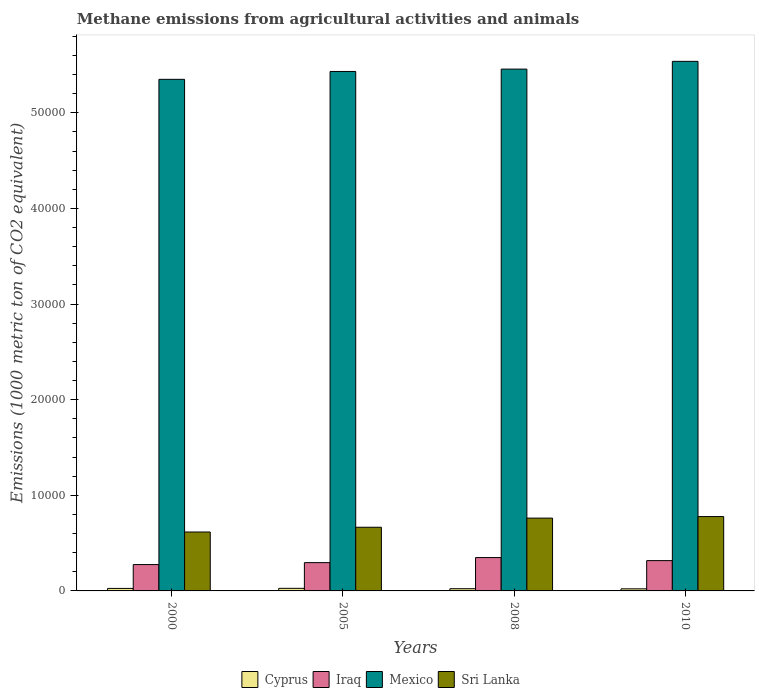Are the number of bars per tick equal to the number of legend labels?
Offer a very short reply. Yes. In how many cases, is the number of bars for a given year not equal to the number of legend labels?
Offer a very short reply. 0. What is the amount of methane emitted in Iraq in 2000?
Offer a terse response. 2756.2. Across all years, what is the maximum amount of methane emitted in Sri Lanka?
Provide a succinct answer. 7775.6. Across all years, what is the minimum amount of methane emitted in Sri Lanka?
Provide a short and direct response. 6161. What is the total amount of methane emitted in Mexico in the graph?
Ensure brevity in your answer.  2.18e+05. What is the difference between the amount of methane emitted in Cyprus in 2000 and that in 2005?
Offer a very short reply. -9.3. What is the difference between the amount of methane emitted in Iraq in 2008 and the amount of methane emitted in Mexico in 2000?
Provide a succinct answer. -5.00e+04. What is the average amount of methane emitted in Iraq per year?
Your answer should be very brief. 3092.72. In the year 2008, what is the difference between the amount of methane emitted in Iraq and amount of methane emitted in Sri Lanka?
Make the answer very short. -4127. In how many years, is the amount of methane emitted in Sri Lanka greater than 24000 1000 metric ton?
Your answer should be very brief. 0. What is the ratio of the amount of methane emitted in Iraq in 2005 to that in 2008?
Make the answer very short. 0.85. Is the amount of methane emitted in Mexico in 2000 less than that in 2008?
Make the answer very short. Yes. Is the difference between the amount of methane emitted in Iraq in 2000 and 2010 greater than the difference between the amount of methane emitted in Sri Lanka in 2000 and 2010?
Offer a very short reply. Yes. What is the difference between the highest and the second highest amount of methane emitted in Cyprus?
Provide a short and direct response. 9.3. What is the difference between the highest and the lowest amount of methane emitted in Iraq?
Offer a very short reply. 731.3. In how many years, is the amount of methane emitted in Iraq greater than the average amount of methane emitted in Iraq taken over all years?
Your answer should be compact. 2. Is the sum of the amount of methane emitted in Mexico in 2005 and 2008 greater than the maximum amount of methane emitted in Sri Lanka across all years?
Provide a succinct answer. Yes. What does the 2nd bar from the left in 2005 represents?
Give a very brief answer. Iraq. What does the 1st bar from the right in 2008 represents?
Your answer should be compact. Sri Lanka. Is it the case that in every year, the sum of the amount of methane emitted in Iraq and amount of methane emitted in Mexico is greater than the amount of methane emitted in Sri Lanka?
Provide a short and direct response. Yes. How many bars are there?
Your response must be concise. 16. What is the difference between two consecutive major ticks on the Y-axis?
Your answer should be very brief. 10000. Does the graph contain grids?
Make the answer very short. No. How are the legend labels stacked?
Give a very brief answer. Horizontal. What is the title of the graph?
Keep it short and to the point. Methane emissions from agricultural activities and animals. Does "Sub-Saharan Africa (all income levels)" appear as one of the legend labels in the graph?
Your answer should be compact. No. What is the label or title of the X-axis?
Your answer should be very brief. Years. What is the label or title of the Y-axis?
Your response must be concise. Emissions (1000 metric ton of CO2 equivalent). What is the Emissions (1000 metric ton of CO2 equivalent) of Cyprus in 2000?
Give a very brief answer. 261.7. What is the Emissions (1000 metric ton of CO2 equivalent) in Iraq in 2000?
Give a very brief answer. 2756.2. What is the Emissions (1000 metric ton of CO2 equivalent) of Mexico in 2000?
Give a very brief answer. 5.35e+04. What is the Emissions (1000 metric ton of CO2 equivalent) in Sri Lanka in 2000?
Make the answer very short. 6161. What is the Emissions (1000 metric ton of CO2 equivalent) of Cyprus in 2005?
Ensure brevity in your answer.  271. What is the Emissions (1000 metric ton of CO2 equivalent) of Iraq in 2005?
Your answer should be very brief. 2958.3. What is the Emissions (1000 metric ton of CO2 equivalent) of Mexico in 2005?
Give a very brief answer. 5.43e+04. What is the Emissions (1000 metric ton of CO2 equivalent) of Sri Lanka in 2005?
Provide a succinct answer. 6658.4. What is the Emissions (1000 metric ton of CO2 equivalent) of Cyprus in 2008?
Your answer should be very brief. 231.7. What is the Emissions (1000 metric ton of CO2 equivalent) in Iraq in 2008?
Provide a succinct answer. 3487.5. What is the Emissions (1000 metric ton of CO2 equivalent) in Mexico in 2008?
Ensure brevity in your answer.  5.46e+04. What is the Emissions (1000 metric ton of CO2 equivalent) in Sri Lanka in 2008?
Make the answer very short. 7614.5. What is the Emissions (1000 metric ton of CO2 equivalent) in Cyprus in 2010?
Provide a short and direct response. 217.6. What is the Emissions (1000 metric ton of CO2 equivalent) in Iraq in 2010?
Offer a very short reply. 3168.9. What is the Emissions (1000 metric ton of CO2 equivalent) of Mexico in 2010?
Your answer should be very brief. 5.54e+04. What is the Emissions (1000 metric ton of CO2 equivalent) in Sri Lanka in 2010?
Provide a succinct answer. 7775.6. Across all years, what is the maximum Emissions (1000 metric ton of CO2 equivalent) of Cyprus?
Your answer should be compact. 271. Across all years, what is the maximum Emissions (1000 metric ton of CO2 equivalent) of Iraq?
Keep it short and to the point. 3487.5. Across all years, what is the maximum Emissions (1000 metric ton of CO2 equivalent) of Mexico?
Ensure brevity in your answer.  5.54e+04. Across all years, what is the maximum Emissions (1000 metric ton of CO2 equivalent) in Sri Lanka?
Ensure brevity in your answer.  7775.6. Across all years, what is the minimum Emissions (1000 metric ton of CO2 equivalent) of Cyprus?
Give a very brief answer. 217.6. Across all years, what is the minimum Emissions (1000 metric ton of CO2 equivalent) of Iraq?
Provide a short and direct response. 2756.2. Across all years, what is the minimum Emissions (1000 metric ton of CO2 equivalent) in Mexico?
Offer a very short reply. 5.35e+04. Across all years, what is the minimum Emissions (1000 metric ton of CO2 equivalent) in Sri Lanka?
Give a very brief answer. 6161. What is the total Emissions (1000 metric ton of CO2 equivalent) of Cyprus in the graph?
Give a very brief answer. 982. What is the total Emissions (1000 metric ton of CO2 equivalent) in Iraq in the graph?
Offer a very short reply. 1.24e+04. What is the total Emissions (1000 metric ton of CO2 equivalent) of Mexico in the graph?
Keep it short and to the point. 2.18e+05. What is the total Emissions (1000 metric ton of CO2 equivalent) of Sri Lanka in the graph?
Give a very brief answer. 2.82e+04. What is the difference between the Emissions (1000 metric ton of CO2 equivalent) of Cyprus in 2000 and that in 2005?
Your response must be concise. -9.3. What is the difference between the Emissions (1000 metric ton of CO2 equivalent) of Iraq in 2000 and that in 2005?
Provide a short and direct response. -202.1. What is the difference between the Emissions (1000 metric ton of CO2 equivalent) in Mexico in 2000 and that in 2005?
Ensure brevity in your answer.  -824. What is the difference between the Emissions (1000 metric ton of CO2 equivalent) of Sri Lanka in 2000 and that in 2005?
Give a very brief answer. -497.4. What is the difference between the Emissions (1000 metric ton of CO2 equivalent) in Cyprus in 2000 and that in 2008?
Keep it short and to the point. 30. What is the difference between the Emissions (1000 metric ton of CO2 equivalent) in Iraq in 2000 and that in 2008?
Your answer should be compact. -731.3. What is the difference between the Emissions (1000 metric ton of CO2 equivalent) in Mexico in 2000 and that in 2008?
Offer a very short reply. -1070.7. What is the difference between the Emissions (1000 metric ton of CO2 equivalent) of Sri Lanka in 2000 and that in 2008?
Provide a succinct answer. -1453.5. What is the difference between the Emissions (1000 metric ton of CO2 equivalent) of Cyprus in 2000 and that in 2010?
Give a very brief answer. 44.1. What is the difference between the Emissions (1000 metric ton of CO2 equivalent) in Iraq in 2000 and that in 2010?
Your answer should be compact. -412.7. What is the difference between the Emissions (1000 metric ton of CO2 equivalent) of Mexico in 2000 and that in 2010?
Provide a short and direct response. -1881.2. What is the difference between the Emissions (1000 metric ton of CO2 equivalent) in Sri Lanka in 2000 and that in 2010?
Provide a short and direct response. -1614.6. What is the difference between the Emissions (1000 metric ton of CO2 equivalent) in Cyprus in 2005 and that in 2008?
Your response must be concise. 39.3. What is the difference between the Emissions (1000 metric ton of CO2 equivalent) in Iraq in 2005 and that in 2008?
Your response must be concise. -529.2. What is the difference between the Emissions (1000 metric ton of CO2 equivalent) in Mexico in 2005 and that in 2008?
Make the answer very short. -246.7. What is the difference between the Emissions (1000 metric ton of CO2 equivalent) in Sri Lanka in 2005 and that in 2008?
Keep it short and to the point. -956.1. What is the difference between the Emissions (1000 metric ton of CO2 equivalent) of Cyprus in 2005 and that in 2010?
Offer a terse response. 53.4. What is the difference between the Emissions (1000 metric ton of CO2 equivalent) of Iraq in 2005 and that in 2010?
Provide a short and direct response. -210.6. What is the difference between the Emissions (1000 metric ton of CO2 equivalent) of Mexico in 2005 and that in 2010?
Provide a succinct answer. -1057.2. What is the difference between the Emissions (1000 metric ton of CO2 equivalent) of Sri Lanka in 2005 and that in 2010?
Your answer should be very brief. -1117.2. What is the difference between the Emissions (1000 metric ton of CO2 equivalent) of Cyprus in 2008 and that in 2010?
Your response must be concise. 14.1. What is the difference between the Emissions (1000 metric ton of CO2 equivalent) of Iraq in 2008 and that in 2010?
Offer a terse response. 318.6. What is the difference between the Emissions (1000 metric ton of CO2 equivalent) in Mexico in 2008 and that in 2010?
Make the answer very short. -810.5. What is the difference between the Emissions (1000 metric ton of CO2 equivalent) in Sri Lanka in 2008 and that in 2010?
Make the answer very short. -161.1. What is the difference between the Emissions (1000 metric ton of CO2 equivalent) in Cyprus in 2000 and the Emissions (1000 metric ton of CO2 equivalent) in Iraq in 2005?
Provide a short and direct response. -2696.6. What is the difference between the Emissions (1000 metric ton of CO2 equivalent) of Cyprus in 2000 and the Emissions (1000 metric ton of CO2 equivalent) of Mexico in 2005?
Give a very brief answer. -5.41e+04. What is the difference between the Emissions (1000 metric ton of CO2 equivalent) in Cyprus in 2000 and the Emissions (1000 metric ton of CO2 equivalent) in Sri Lanka in 2005?
Your answer should be compact. -6396.7. What is the difference between the Emissions (1000 metric ton of CO2 equivalent) in Iraq in 2000 and the Emissions (1000 metric ton of CO2 equivalent) in Mexico in 2005?
Make the answer very short. -5.16e+04. What is the difference between the Emissions (1000 metric ton of CO2 equivalent) in Iraq in 2000 and the Emissions (1000 metric ton of CO2 equivalent) in Sri Lanka in 2005?
Your response must be concise. -3902.2. What is the difference between the Emissions (1000 metric ton of CO2 equivalent) in Mexico in 2000 and the Emissions (1000 metric ton of CO2 equivalent) in Sri Lanka in 2005?
Your response must be concise. 4.68e+04. What is the difference between the Emissions (1000 metric ton of CO2 equivalent) of Cyprus in 2000 and the Emissions (1000 metric ton of CO2 equivalent) of Iraq in 2008?
Your answer should be very brief. -3225.8. What is the difference between the Emissions (1000 metric ton of CO2 equivalent) in Cyprus in 2000 and the Emissions (1000 metric ton of CO2 equivalent) in Mexico in 2008?
Your answer should be very brief. -5.43e+04. What is the difference between the Emissions (1000 metric ton of CO2 equivalent) of Cyprus in 2000 and the Emissions (1000 metric ton of CO2 equivalent) of Sri Lanka in 2008?
Provide a short and direct response. -7352.8. What is the difference between the Emissions (1000 metric ton of CO2 equivalent) of Iraq in 2000 and the Emissions (1000 metric ton of CO2 equivalent) of Mexico in 2008?
Offer a terse response. -5.18e+04. What is the difference between the Emissions (1000 metric ton of CO2 equivalent) in Iraq in 2000 and the Emissions (1000 metric ton of CO2 equivalent) in Sri Lanka in 2008?
Ensure brevity in your answer.  -4858.3. What is the difference between the Emissions (1000 metric ton of CO2 equivalent) in Mexico in 2000 and the Emissions (1000 metric ton of CO2 equivalent) in Sri Lanka in 2008?
Offer a terse response. 4.59e+04. What is the difference between the Emissions (1000 metric ton of CO2 equivalent) in Cyprus in 2000 and the Emissions (1000 metric ton of CO2 equivalent) in Iraq in 2010?
Your answer should be very brief. -2907.2. What is the difference between the Emissions (1000 metric ton of CO2 equivalent) in Cyprus in 2000 and the Emissions (1000 metric ton of CO2 equivalent) in Mexico in 2010?
Provide a succinct answer. -5.51e+04. What is the difference between the Emissions (1000 metric ton of CO2 equivalent) in Cyprus in 2000 and the Emissions (1000 metric ton of CO2 equivalent) in Sri Lanka in 2010?
Give a very brief answer. -7513.9. What is the difference between the Emissions (1000 metric ton of CO2 equivalent) of Iraq in 2000 and the Emissions (1000 metric ton of CO2 equivalent) of Mexico in 2010?
Keep it short and to the point. -5.26e+04. What is the difference between the Emissions (1000 metric ton of CO2 equivalent) of Iraq in 2000 and the Emissions (1000 metric ton of CO2 equivalent) of Sri Lanka in 2010?
Your response must be concise. -5019.4. What is the difference between the Emissions (1000 metric ton of CO2 equivalent) in Mexico in 2000 and the Emissions (1000 metric ton of CO2 equivalent) in Sri Lanka in 2010?
Provide a short and direct response. 4.57e+04. What is the difference between the Emissions (1000 metric ton of CO2 equivalent) of Cyprus in 2005 and the Emissions (1000 metric ton of CO2 equivalent) of Iraq in 2008?
Your answer should be very brief. -3216.5. What is the difference between the Emissions (1000 metric ton of CO2 equivalent) of Cyprus in 2005 and the Emissions (1000 metric ton of CO2 equivalent) of Mexico in 2008?
Keep it short and to the point. -5.43e+04. What is the difference between the Emissions (1000 metric ton of CO2 equivalent) in Cyprus in 2005 and the Emissions (1000 metric ton of CO2 equivalent) in Sri Lanka in 2008?
Your response must be concise. -7343.5. What is the difference between the Emissions (1000 metric ton of CO2 equivalent) in Iraq in 2005 and the Emissions (1000 metric ton of CO2 equivalent) in Mexico in 2008?
Make the answer very short. -5.16e+04. What is the difference between the Emissions (1000 metric ton of CO2 equivalent) of Iraq in 2005 and the Emissions (1000 metric ton of CO2 equivalent) of Sri Lanka in 2008?
Offer a very short reply. -4656.2. What is the difference between the Emissions (1000 metric ton of CO2 equivalent) of Mexico in 2005 and the Emissions (1000 metric ton of CO2 equivalent) of Sri Lanka in 2008?
Offer a very short reply. 4.67e+04. What is the difference between the Emissions (1000 metric ton of CO2 equivalent) in Cyprus in 2005 and the Emissions (1000 metric ton of CO2 equivalent) in Iraq in 2010?
Make the answer very short. -2897.9. What is the difference between the Emissions (1000 metric ton of CO2 equivalent) in Cyprus in 2005 and the Emissions (1000 metric ton of CO2 equivalent) in Mexico in 2010?
Provide a short and direct response. -5.51e+04. What is the difference between the Emissions (1000 metric ton of CO2 equivalent) of Cyprus in 2005 and the Emissions (1000 metric ton of CO2 equivalent) of Sri Lanka in 2010?
Ensure brevity in your answer.  -7504.6. What is the difference between the Emissions (1000 metric ton of CO2 equivalent) in Iraq in 2005 and the Emissions (1000 metric ton of CO2 equivalent) in Mexico in 2010?
Your answer should be very brief. -5.24e+04. What is the difference between the Emissions (1000 metric ton of CO2 equivalent) in Iraq in 2005 and the Emissions (1000 metric ton of CO2 equivalent) in Sri Lanka in 2010?
Offer a terse response. -4817.3. What is the difference between the Emissions (1000 metric ton of CO2 equivalent) of Mexico in 2005 and the Emissions (1000 metric ton of CO2 equivalent) of Sri Lanka in 2010?
Offer a very short reply. 4.66e+04. What is the difference between the Emissions (1000 metric ton of CO2 equivalent) in Cyprus in 2008 and the Emissions (1000 metric ton of CO2 equivalent) in Iraq in 2010?
Offer a terse response. -2937.2. What is the difference between the Emissions (1000 metric ton of CO2 equivalent) of Cyprus in 2008 and the Emissions (1000 metric ton of CO2 equivalent) of Mexico in 2010?
Your answer should be very brief. -5.52e+04. What is the difference between the Emissions (1000 metric ton of CO2 equivalent) in Cyprus in 2008 and the Emissions (1000 metric ton of CO2 equivalent) in Sri Lanka in 2010?
Make the answer very short. -7543.9. What is the difference between the Emissions (1000 metric ton of CO2 equivalent) of Iraq in 2008 and the Emissions (1000 metric ton of CO2 equivalent) of Mexico in 2010?
Your answer should be very brief. -5.19e+04. What is the difference between the Emissions (1000 metric ton of CO2 equivalent) of Iraq in 2008 and the Emissions (1000 metric ton of CO2 equivalent) of Sri Lanka in 2010?
Provide a short and direct response. -4288.1. What is the difference between the Emissions (1000 metric ton of CO2 equivalent) in Mexico in 2008 and the Emissions (1000 metric ton of CO2 equivalent) in Sri Lanka in 2010?
Offer a very short reply. 4.68e+04. What is the average Emissions (1000 metric ton of CO2 equivalent) of Cyprus per year?
Your answer should be compact. 245.5. What is the average Emissions (1000 metric ton of CO2 equivalent) in Iraq per year?
Provide a succinct answer. 3092.72. What is the average Emissions (1000 metric ton of CO2 equivalent) of Mexico per year?
Provide a short and direct response. 5.44e+04. What is the average Emissions (1000 metric ton of CO2 equivalent) of Sri Lanka per year?
Ensure brevity in your answer.  7052.38. In the year 2000, what is the difference between the Emissions (1000 metric ton of CO2 equivalent) in Cyprus and Emissions (1000 metric ton of CO2 equivalent) in Iraq?
Your response must be concise. -2494.5. In the year 2000, what is the difference between the Emissions (1000 metric ton of CO2 equivalent) of Cyprus and Emissions (1000 metric ton of CO2 equivalent) of Mexico?
Offer a very short reply. -5.32e+04. In the year 2000, what is the difference between the Emissions (1000 metric ton of CO2 equivalent) in Cyprus and Emissions (1000 metric ton of CO2 equivalent) in Sri Lanka?
Your answer should be compact. -5899.3. In the year 2000, what is the difference between the Emissions (1000 metric ton of CO2 equivalent) in Iraq and Emissions (1000 metric ton of CO2 equivalent) in Mexico?
Your answer should be very brief. -5.07e+04. In the year 2000, what is the difference between the Emissions (1000 metric ton of CO2 equivalent) in Iraq and Emissions (1000 metric ton of CO2 equivalent) in Sri Lanka?
Keep it short and to the point. -3404.8. In the year 2000, what is the difference between the Emissions (1000 metric ton of CO2 equivalent) of Mexico and Emissions (1000 metric ton of CO2 equivalent) of Sri Lanka?
Provide a short and direct response. 4.73e+04. In the year 2005, what is the difference between the Emissions (1000 metric ton of CO2 equivalent) of Cyprus and Emissions (1000 metric ton of CO2 equivalent) of Iraq?
Your response must be concise. -2687.3. In the year 2005, what is the difference between the Emissions (1000 metric ton of CO2 equivalent) of Cyprus and Emissions (1000 metric ton of CO2 equivalent) of Mexico?
Make the answer very short. -5.41e+04. In the year 2005, what is the difference between the Emissions (1000 metric ton of CO2 equivalent) in Cyprus and Emissions (1000 metric ton of CO2 equivalent) in Sri Lanka?
Provide a short and direct response. -6387.4. In the year 2005, what is the difference between the Emissions (1000 metric ton of CO2 equivalent) in Iraq and Emissions (1000 metric ton of CO2 equivalent) in Mexico?
Your response must be concise. -5.14e+04. In the year 2005, what is the difference between the Emissions (1000 metric ton of CO2 equivalent) in Iraq and Emissions (1000 metric ton of CO2 equivalent) in Sri Lanka?
Offer a terse response. -3700.1. In the year 2005, what is the difference between the Emissions (1000 metric ton of CO2 equivalent) of Mexico and Emissions (1000 metric ton of CO2 equivalent) of Sri Lanka?
Ensure brevity in your answer.  4.77e+04. In the year 2008, what is the difference between the Emissions (1000 metric ton of CO2 equivalent) in Cyprus and Emissions (1000 metric ton of CO2 equivalent) in Iraq?
Make the answer very short. -3255.8. In the year 2008, what is the difference between the Emissions (1000 metric ton of CO2 equivalent) of Cyprus and Emissions (1000 metric ton of CO2 equivalent) of Mexico?
Make the answer very short. -5.43e+04. In the year 2008, what is the difference between the Emissions (1000 metric ton of CO2 equivalent) in Cyprus and Emissions (1000 metric ton of CO2 equivalent) in Sri Lanka?
Offer a terse response. -7382.8. In the year 2008, what is the difference between the Emissions (1000 metric ton of CO2 equivalent) in Iraq and Emissions (1000 metric ton of CO2 equivalent) in Mexico?
Provide a short and direct response. -5.11e+04. In the year 2008, what is the difference between the Emissions (1000 metric ton of CO2 equivalent) of Iraq and Emissions (1000 metric ton of CO2 equivalent) of Sri Lanka?
Offer a terse response. -4127. In the year 2008, what is the difference between the Emissions (1000 metric ton of CO2 equivalent) of Mexico and Emissions (1000 metric ton of CO2 equivalent) of Sri Lanka?
Offer a terse response. 4.70e+04. In the year 2010, what is the difference between the Emissions (1000 metric ton of CO2 equivalent) in Cyprus and Emissions (1000 metric ton of CO2 equivalent) in Iraq?
Make the answer very short. -2951.3. In the year 2010, what is the difference between the Emissions (1000 metric ton of CO2 equivalent) in Cyprus and Emissions (1000 metric ton of CO2 equivalent) in Mexico?
Offer a terse response. -5.52e+04. In the year 2010, what is the difference between the Emissions (1000 metric ton of CO2 equivalent) in Cyprus and Emissions (1000 metric ton of CO2 equivalent) in Sri Lanka?
Offer a very short reply. -7558. In the year 2010, what is the difference between the Emissions (1000 metric ton of CO2 equivalent) of Iraq and Emissions (1000 metric ton of CO2 equivalent) of Mexico?
Offer a terse response. -5.22e+04. In the year 2010, what is the difference between the Emissions (1000 metric ton of CO2 equivalent) of Iraq and Emissions (1000 metric ton of CO2 equivalent) of Sri Lanka?
Provide a succinct answer. -4606.7. In the year 2010, what is the difference between the Emissions (1000 metric ton of CO2 equivalent) in Mexico and Emissions (1000 metric ton of CO2 equivalent) in Sri Lanka?
Offer a very short reply. 4.76e+04. What is the ratio of the Emissions (1000 metric ton of CO2 equivalent) in Cyprus in 2000 to that in 2005?
Provide a succinct answer. 0.97. What is the ratio of the Emissions (1000 metric ton of CO2 equivalent) in Iraq in 2000 to that in 2005?
Keep it short and to the point. 0.93. What is the ratio of the Emissions (1000 metric ton of CO2 equivalent) of Sri Lanka in 2000 to that in 2005?
Offer a terse response. 0.93. What is the ratio of the Emissions (1000 metric ton of CO2 equivalent) in Cyprus in 2000 to that in 2008?
Offer a very short reply. 1.13. What is the ratio of the Emissions (1000 metric ton of CO2 equivalent) in Iraq in 2000 to that in 2008?
Your response must be concise. 0.79. What is the ratio of the Emissions (1000 metric ton of CO2 equivalent) of Mexico in 2000 to that in 2008?
Your answer should be compact. 0.98. What is the ratio of the Emissions (1000 metric ton of CO2 equivalent) of Sri Lanka in 2000 to that in 2008?
Provide a succinct answer. 0.81. What is the ratio of the Emissions (1000 metric ton of CO2 equivalent) in Cyprus in 2000 to that in 2010?
Your response must be concise. 1.2. What is the ratio of the Emissions (1000 metric ton of CO2 equivalent) of Iraq in 2000 to that in 2010?
Your answer should be very brief. 0.87. What is the ratio of the Emissions (1000 metric ton of CO2 equivalent) in Mexico in 2000 to that in 2010?
Provide a short and direct response. 0.97. What is the ratio of the Emissions (1000 metric ton of CO2 equivalent) in Sri Lanka in 2000 to that in 2010?
Keep it short and to the point. 0.79. What is the ratio of the Emissions (1000 metric ton of CO2 equivalent) in Cyprus in 2005 to that in 2008?
Offer a very short reply. 1.17. What is the ratio of the Emissions (1000 metric ton of CO2 equivalent) in Iraq in 2005 to that in 2008?
Ensure brevity in your answer.  0.85. What is the ratio of the Emissions (1000 metric ton of CO2 equivalent) in Mexico in 2005 to that in 2008?
Your answer should be very brief. 1. What is the ratio of the Emissions (1000 metric ton of CO2 equivalent) of Sri Lanka in 2005 to that in 2008?
Keep it short and to the point. 0.87. What is the ratio of the Emissions (1000 metric ton of CO2 equivalent) of Cyprus in 2005 to that in 2010?
Offer a very short reply. 1.25. What is the ratio of the Emissions (1000 metric ton of CO2 equivalent) in Iraq in 2005 to that in 2010?
Make the answer very short. 0.93. What is the ratio of the Emissions (1000 metric ton of CO2 equivalent) of Mexico in 2005 to that in 2010?
Ensure brevity in your answer.  0.98. What is the ratio of the Emissions (1000 metric ton of CO2 equivalent) in Sri Lanka in 2005 to that in 2010?
Provide a short and direct response. 0.86. What is the ratio of the Emissions (1000 metric ton of CO2 equivalent) of Cyprus in 2008 to that in 2010?
Your answer should be very brief. 1.06. What is the ratio of the Emissions (1000 metric ton of CO2 equivalent) of Iraq in 2008 to that in 2010?
Make the answer very short. 1.1. What is the ratio of the Emissions (1000 metric ton of CO2 equivalent) in Mexico in 2008 to that in 2010?
Keep it short and to the point. 0.99. What is the ratio of the Emissions (1000 metric ton of CO2 equivalent) in Sri Lanka in 2008 to that in 2010?
Your response must be concise. 0.98. What is the difference between the highest and the second highest Emissions (1000 metric ton of CO2 equivalent) in Iraq?
Provide a succinct answer. 318.6. What is the difference between the highest and the second highest Emissions (1000 metric ton of CO2 equivalent) of Mexico?
Your answer should be compact. 810.5. What is the difference between the highest and the second highest Emissions (1000 metric ton of CO2 equivalent) of Sri Lanka?
Your answer should be very brief. 161.1. What is the difference between the highest and the lowest Emissions (1000 metric ton of CO2 equivalent) in Cyprus?
Ensure brevity in your answer.  53.4. What is the difference between the highest and the lowest Emissions (1000 metric ton of CO2 equivalent) in Iraq?
Make the answer very short. 731.3. What is the difference between the highest and the lowest Emissions (1000 metric ton of CO2 equivalent) of Mexico?
Provide a short and direct response. 1881.2. What is the difference between the highest and the lowest Emissions (1000 metric ton of CO2 equivalent) in Sri Lanka?
Ensure brevity in your answer.  1614.6. 